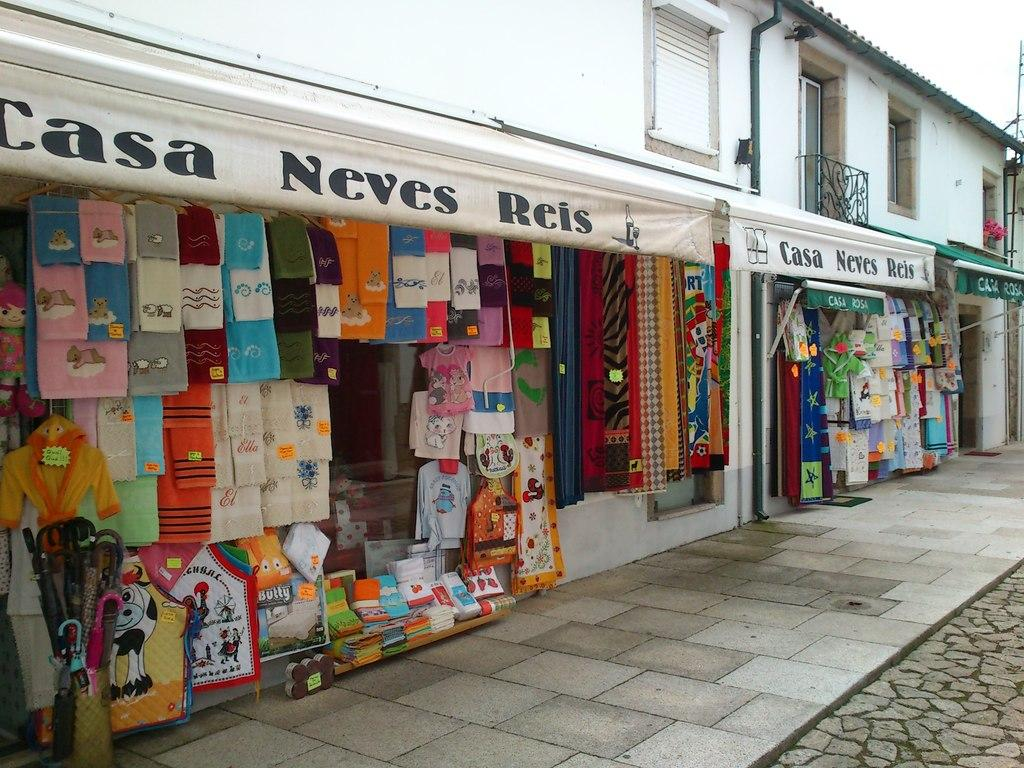<image>
Write a terse but informative summary of the picture. A display of towels hanging outside a store named Casa Neves Reis. 